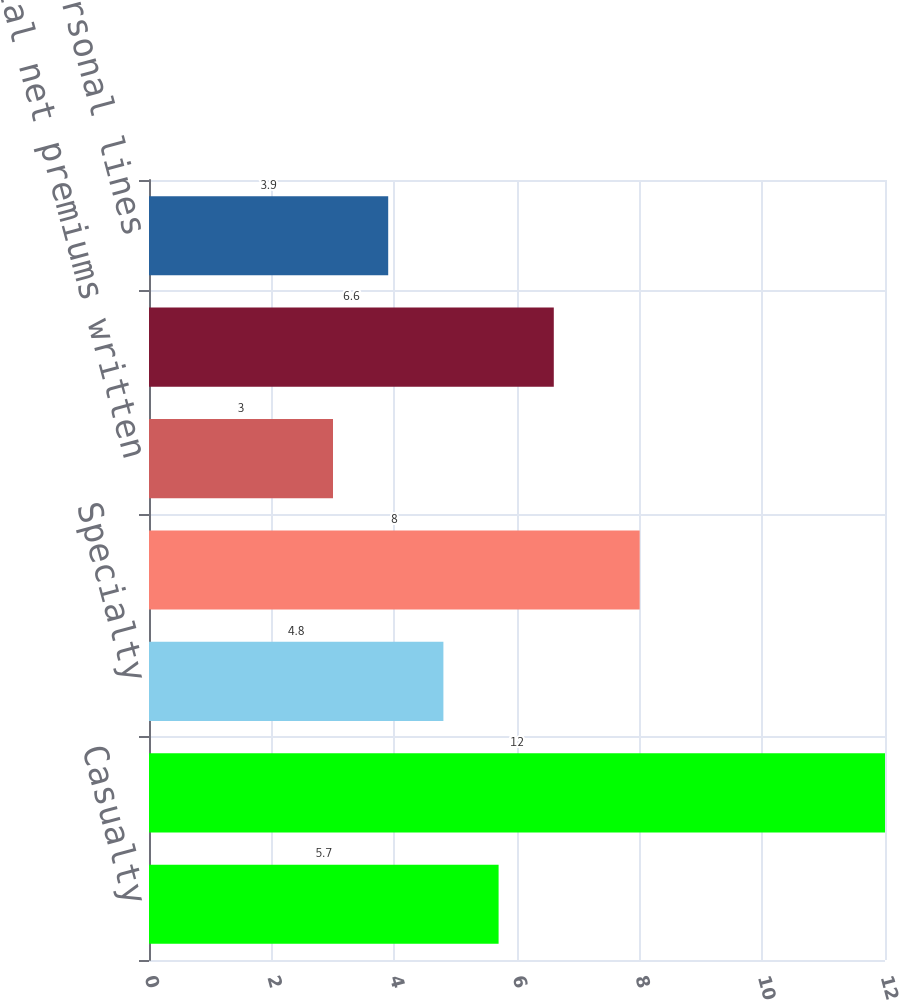<chart> <loc_0><loc_0><loc_500><loc_500><bar_chart><fcel>Casualty<fcel>Property<fcel>Specialty<fcel>Financial lines<fcel>Total net premiums written<fcel>Accident & Health<fcel>Personal lines<nl><fcel>5.7<fcel>12<fcel>4.8<fcel>8<fcel>3<fcel>6.6<fcel>3.9<nl></chart> 